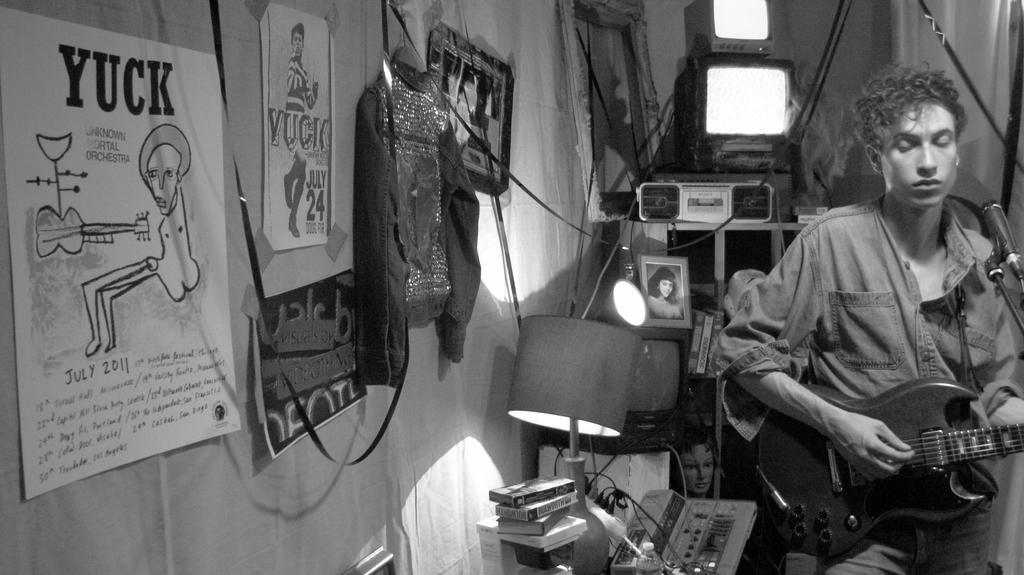Could you give a brief overview of what you see in this image? There is a person on the right side. He is holding a guitar in his hand and he is singing on a microphone. In the background we can see a television , a tape recorder, a table lamp and a photo frame. 